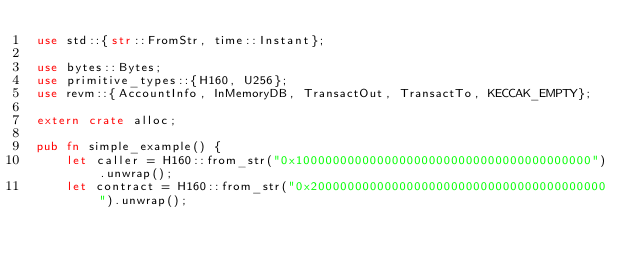<code> <loc_0><loc_0><loc_500><loc_500><_Rust_>use std::{str::FromStr, time::Instant};

use bytes::Bytes;
use primitive_types::{H160, U256};
use revm::{AccountInfo, InMemoryDB, TransactOut, TransactTo, KECCAK_EMPTY};

extern crate alloc;

pub fn simple_example() {
    let caller = H160::from_str("0x1000000000000000000000000000000000000000").unwrap();
    let contract = H160::from_str("0x2000000000000000000000000000000000000000").unwrap();</code> 